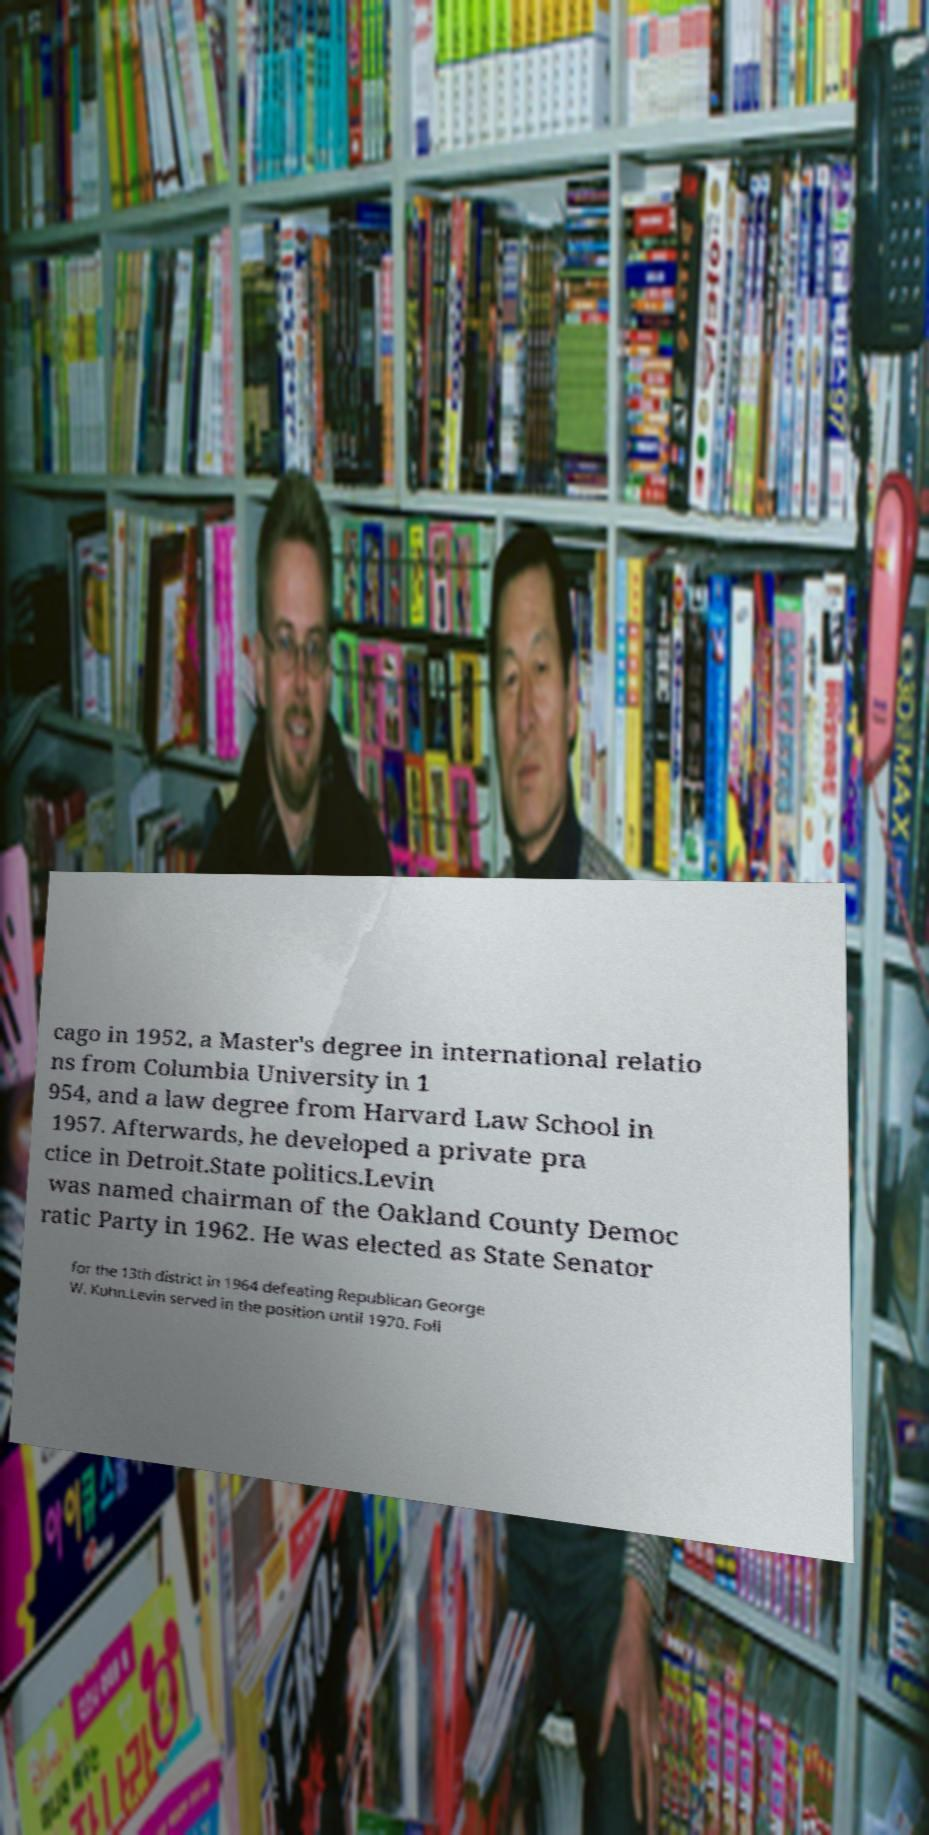For documentation purposes, I need the text within this image transcribed. Could you provide that? cago in 1952, a Master's degree in international relatio ns from Columbia University in 1 954, and a law degree from Harvard Law School in 1957. Afterwards, he developed a private pra ctice in Detroit.State politics.Levin was named chairman of the Oakland County Democ ratic Party in 1962. He was elected as State Senator for the 13th district in 1964 defeating Republican George W. Kuhn.Levin served in the position until 1970. Foll 